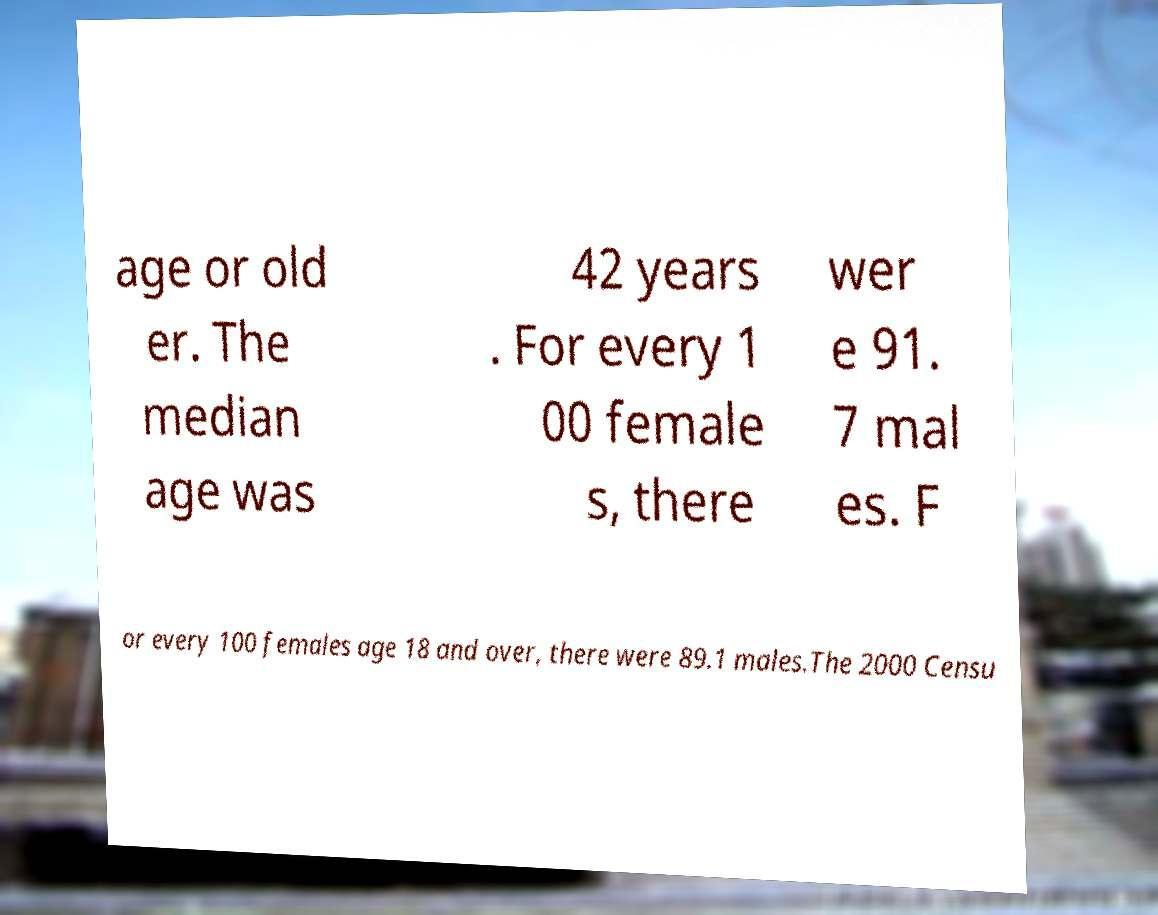Could you extract and type out the text from this image? age or old er. The median age was 42 years . For every 1 00 female s, there wer e 91. 7 mal es. F or every 100 females age 18 and over, there were 89.1 males.The 2000 Censu 